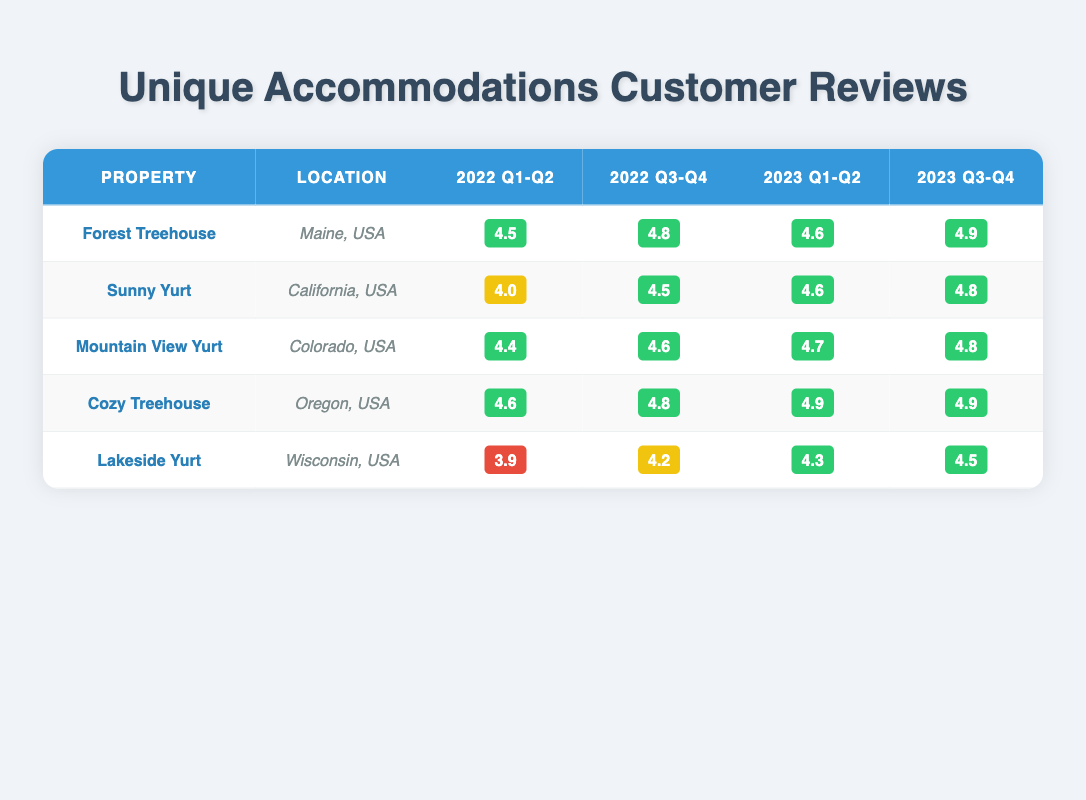What is the highest rating received by the Forest Treehouse? The ratings for the Forest Treehouse are 4.5, 4.7, 4.8, 4.6, and 4.9 from January 2022 to June 2023. Among these, 4.9 is the highest rating.
Answer: 4.9 What was the average rating for the Cozy Treehouse in the second half of 2022? The ratings for the Cozy Treehouse in the second half of 2022 are 4.8 and 4.9. Adding these ratings gives us 4.8 + 4.9 = 9.7. Since there are 2 ratings, the average is 9.7 / 2 = 4.85.
Answer: 4.85 Did any property have a rating lower than 4.0 in the first half of 2022? The ratings in the first half of 2022 for all properties are: Forest Treehouse (4.5), Sunny Yurt (4.0), Mountain View Yurt (4.4), Cozy Treehouse (4.6), and Lakeside Yurt (3.9). Since Lakeside Yurt (3.9) is lower than 4.0, the answer is yes.
Answer: Yes Which yurt had the highest rating in the first half of 2023? For the first half of 2023, the ratings are: Sunny Yurt (4.6), Mountain View Yurt (4.7), and Lakeside Yurt (4.3). The highest among these is 4.7 from the Mountain View Yurt.
Answer: Mountain View Yurt What is the rating difference between the best and worst rating of Lakeside Yurt? The best rating for Lakeside Yurt is 4.5 (in October 2023) and the worst is 3.9 (in May 2022). The difference is 4.5 - 3.9 = 0.6.
Answer: 0.6 What was the trend of ratings for the Cozy Treehouse from 2022 to 2023? The ratings for Cozy Treehouse are 4.6 (Q1-Q2 2022), 4.8 (Q3-Q4 2022), 4.9 (Q1-Q2 2023), and 4.9 (Q3-Q4 2023). This indicates an upward trend from 4.6 to 4.9, which then remains constant.
Answer: Upward trend then constant Which property had the most consistent ratings over time? To determine consistency, we look at the variability of ratings among the properties. Cozy Treehouse has ratings of 4.6, 4.8, 4.9, and 4.9, with minimal fluctuation, indicating high consistency.
Answer: Cozy Treehouse What was the increase in rating for Sunny Yurt from February 2022 to August 2023? The rating for Sunny Yurt was 4.0 in February 2022 and increased to 4.8 in August 2023. The increase is 4.8 - 4.0 = 0.8.
Answer: 0.8 Was there any property whose rating improved every time from 2022 to 2023? Evaluating each property: Forest Treehouse (4.5 to 4.9), Sunny Yurt (4.0 to 4.8), Mountain View Yurt (4.4 to 4.8), and Cozy Treehouse (4.6 to 4.9) all show improvement. Lakeside Yurt did not improve consistently (3.9 to 4.5). Hence, the answer is yes for the first three.
Answer: Yes 